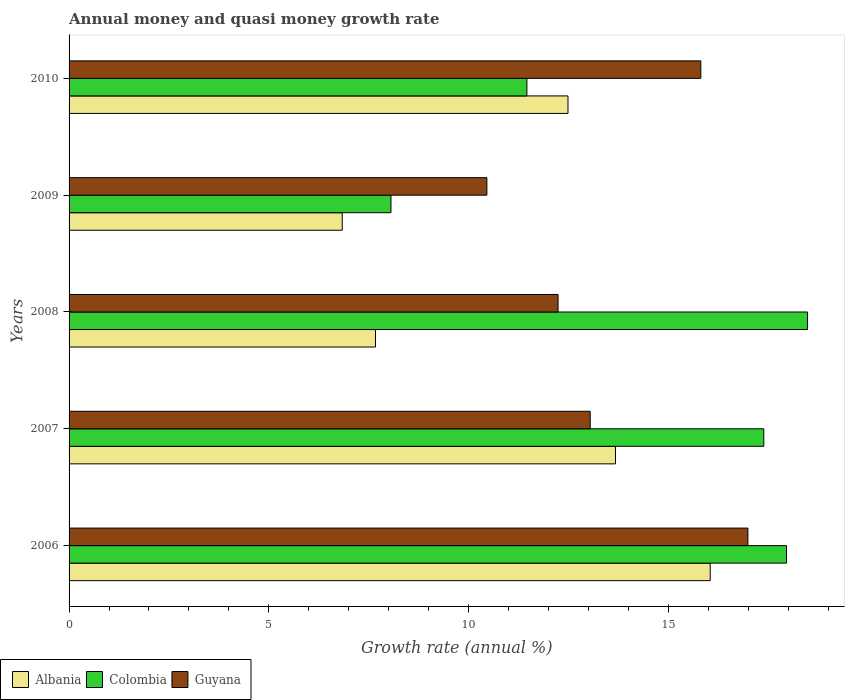Are the number of bars on each tick of the Y-axis equal?
Provide a succinct answer. Yes. What is the label of the 2nd group of bars from the top?
Provide a succinct answer. 2009. In how many cases, is the number of bars for a given year not equal to the number of legend labels?
Your answer should be compact. 0. What is the growth rate in Guyana in 2007?
Give a very brief answer. 13.04. Across all years, what is the maximum growth rate in Colombia?
Your answer should be very brief. 18.48. Across all years, what is the minimum growth rate in Guyana?
Provide a succinct answer. 10.46. In which year was the growth rate in Colombia maximum?
Offer a very short reply. 2008. In which year was the growth rate in Albania minimum?
Your answer should be compact. 2009. What is the total growth rate in Guyana in the graph?
Offer a very short reply. 68.54. What is the difference between the growth rate in Guyana in 2009 and that in 2010?
Your answer should be very brief. -5.35. What is the difference between the growth rate in Albania in 2010 and the growth rate in Guyana in 2007?
Offer a terse response. -0.56. What is the average growth rate in Albania per year?
Keep it short and to the point. 11.34. In the year 2008, what is the difference between the growth rate in Albania and growth rate in Guyana?
Make the answer very short. -4.57. What is the ratio of the growth rate in Guyana in 2008 to that in 2009?
Give a very brief answer. 1.17. Is the growth rate in Albania in 2009 less than that in 2010?
Your answer should be compact. Yes. Is the difference between the growth rate in Albania in 2006 and 2008 greater than the difference between the growth rate in Guyana in 2006 and 2008?
Your answer should be very brief. Yes. What is the difference between the highest and the second highest growth rate in Guyana?
Make the answer very short. 1.18. What is the difference between the highest and the lowest growth rate in Guyana?
Offer a very short reply. 6.53. In how many years, is the growth rate in Albania greater than the average growth rate in Albania taken over all years?
Your answer should be very brief. 3. What does the 3rd bar from the bottom in 2010 represents?
Ensure brevity in your answer.  Guyana. How many years are there in the graph?
Your answer should be very brief. 5. Where does the legend appear in the graph?
Keep it short and to the point. Bottom left. How many legend labels are there?
Your response must be concise. 3. What is the title of the graph?
Keep it short and to the point. Annual money and quasi money growth rate. Does "St. Kitts and Nevis" appear as one of the legend labels in the graph?
Your answer should be very brief. No. What is the label or title of the X-axis?
Your answer should be compact. Growth rate (annual %). What is the Growth rate (annual %) in Albania in 2006?
Give a very brief answer. 16.05. What is the Growth rate (annual %) in Colombia in 2006?
Make the answer very short. 17.95. What is the Growth rate (annual %) of Guyana in 2006?
Your answer should be very brief. 16.99. What is the Growth rate (annual %) of Albania in 2007?
Provide a succinct answer. 13.67. What is the Growth rate (annual %) of Colombia in 2007?
Your answer should be very brief. 17.39. What is the Growth rate (annual %) of Guyana in 2007?
Provide a succinct answer. 13.04. What is the Growth rate (annual %) of Albania in 2008?
Give a very brief answer. 7.67. What is the Growth rate (annual %) in Colombia in 2008?
Offer a terse response. 18.48. What is the Growth rate (annual %) in Guyana in 2008?
Your answer should be compact. 12.24. What is the Growth rate (annual %) of Albania in 2009?
Offer a very short reply. 6.84. What is the Growth rate (annual %) in Colombia in 2009?
Provide a succinct answer. 8.06. What is the Growth rate (annual %) of Guyana in 2009?
Make the answer very short. 10.46. What is the Growth rate (annual %) in Albania in 2010?
Provide a short and direct response. 12.49. What is the Growth rate (annual %) of Colombia in 2010?
Provide a succinct answer. 11.46. What is the Growth rate (annual %) in Guyana in 2010?
Give a very brief answer. 15.81. Across all years, what is the maximum Growth rate (annual %) of Albania?
Your answer should be very brief. 16.05. Across all years, what is the maximum Growth rate (annual %) of Colombia?
Give a very brief answer. 18.48. Across all years, what is the maximum Growth rate (annual %) in Guyana?
Offer a very short reply. 16.99. Across all years, what is the minimum Growth rate (annual %) in Albania?
Offer a very short reply. 6.84. Across all years, what is the minimum Growth rate (annual %) of Colombia?
Provide a succinct answer. 8.06. Across all years, what is the minimum Growth rate (annual %) in Guyana?
Make the answer very short. 10.46. What is the total Growth rate (annual %) of Albania in the graph?
Make the answer very short. 56.71. What is the total Growth rate (annual %) in Colombia in the graph?
Keep it short and to the point. 73.34. What is the total Growth rate (annual %) in Guyana in the graph?
Offer a very short reply. 68.54. What is the difference between the Growth rate (annual %) of Albania in 2006 and that in 2007?
Ensure brevity in your answer.  2.37. What is the difference between the Growth rate (annual %) of Colombia in 2006 and that in 2007?
Provide a short and direct response. 0.57. What is the difference between the Growth rate (annual %) of Guyana in 2006 and that in 2007?
Your answer should be very brief. 3.95. What is the difference between the Growth rate (annual %) of Albania in 2006 and that in 2008?
Give a very brief answer. 8.38. What is the difference between the Growth rate (annual %) in Colombia in 2006 and that in 2008?
Your answer should be compact. -0.53. What is the difference between the Growth rate (annual %) of Guyana in 2006 and that in 2008?
Provide a short and direct response. 4.75. What is the difference between the Growth rate (annual %) of Albania in 2006 and that in 2009?
Provide a short and direct response. 9.21. What is the difference between the Growth rate (annual %) in Colombia in 2006 and that in 2009?
Your answer should be very brief. 9.9. What is the difference between the Growth rate (annual %) in Guyana in 2006 and that in 2009?
Provide a short and direct response. 6.53. What is the difference between the Growth rate (annual %) of Albania in 2006 and that in 2010?
Provide a short and direct response. 3.56. What is the difference between the Growth rate (annual %) in Colombia in 2006 and that in 2010?
Give a very brief answer. 6.5. What is the difference between the Growth rate (annual %) in Guyana in 2006 and that in 2010?
Provide a short and direct response. 1.18. What is the difference between the Growth rate (annual %) of Albania in 2007 and that in 2008?
Keep it short and to the point. 6.01. What is the difference between the Growth rate (annual %) of Colombia in 2007 and that in 2008?
Your response must be concise. -1.1. What is the difference between the Growth rate (annual %) in Guyana in 2007 and that in 2008?
Ensure brevity in your answer.  0.8. What is the difference between the Growth rate (annual %) of Albania in 2007 and that in 2009?
Your response must be concise. 6.84. What is the difference between the Growth rate (annual %) in Colombia in 2007 and that in 2009?
Provide a short and direct response. 9.33. What is the difference between the Growth rate (annual %) of Guyana in 2007 and that in 2009?
Offer a very short reply. 2.59. What is the difference between the Growth rate (annual %) in Albania in 2007 and that in 2010?
Your answer should be very brief. 1.19. What is the difference between the Growth rate (annual %) in Colombia in 2007 and that in 2010?
Give a very brief answer. 5.93. What is the difference between the Growth rate (annual %) of Guyana in 2007 and that in 2010?
Your answer should be compact. -2.77. What is the difference between the Growth rate (annual %) in Albania in 2008 and that in 2009?
Offer a terse response. 0.83. What is the difference between the Growth rate (annual %) of Colombia in 2008 and that in 2009?
Ensure brevity in your answer.  10.43. What is the difference between the Growth rate (annual %) in Guyana in 2008 and that in 2009?
Your answer should be compact. 1.78. What is the difference between the Growth rate (annual %) of Albania in 2008 and that in 2010?
Offer a very short reply. -4.82. What is the difference between the Growth rate (annual %) in Colombia in 2008 and that in 2010?
Provide a succinct answer. 7.02. What is the difference between the Growth rate (annual %) in Guyana in 2008 and that in 2010?
Your answer should be very brief. -3.57. What is the difference between the Growth rate (annual %) of Albania in 2009 and that in 2010?
Give a very brief answer. -5.65. What is the difference between the Growth rate (annual %) in Colombia in 2009 and that in 2010?
Ensure brevity in your answer.  -3.4. What is the difference between the Growth rate (annual %) in Guyana in 2009 and that in 2010?
Provide a short and direct response. -5.35. What is the difference between the Growth rate (annual %) in Albania in 2006 and the Growth rate (annual %) in Colombia in 2007?
Your answer should be very brief. -1.34. What is the difference between the Growth rate (annual %) of Albania in 2006 and the Growth rate (annual %) of Guyana in 2007?
Ensure brevity in your answer.  3. What is the difference between the Growth rate (annual %) of Colombia in 2006 and the Growth rate (annual %) of Guyana in 2007?
Keep it short and to the point. 4.91. What is the difference between the Growth rate (annual %) in Albania in 2006 and the Growth rate (annual %) in Colombia in 2008?
Your answer should be very brief. -2.44. What is the difference between the Growth rate (annual %) of Albania in 2006 and the Growth rate (annual %) of Guyana in 2008?
Your answer should be very brief. 3.81. What is the difference between the Growth rate (annual %) of Colombia in 2006 and the Growth rate (annual %) of Guyana in 2008?
Provide a short and direct response. 5.72. What is the difference between the Growth rate (annual %) in Albania in 2006 and the Growth rate (annual %) in Colombia in 2009?
Provide a short and direct response. 7.99. What is the difference between the Growth rate (annual %) in Albania in 2006 and the Growth rate (annual %) in Guyana in 2009?
Offer a terse response. 5.59. What is the difference between the Growth rate (annual %) in Colombia in 2006 and the Growth rate (annual %) in Guyana in 2009?
Keep it short and to the point. 7.5. What is the difference between the Growth rate (annual %) of Albania in 2006 and the Growth rate (annual %) of Colombia in 2010?
Keep it short and to the point. 4.59. What is the difference between the Growth rate (annual %) in Albania in 2006 and the Growth rate (annual %) in Guyana in 2010?
Make the answer very short. 0.24. What is the difference between the Growth rate (annual %) in Colombia in 2006 and the Growth rate (annual %) in Guyana in 2010?
Give a very brief answer. 2.14. What is the difference between the Growth rate (annual %) in Albania in 2007 and the Growth rate (annual %) in Colombia in 2008?
Make the answer very short. -4.81. What is the difference between the Growth rate (annual %) in Albania in 2007 and the Growth rate (annual %) in Guyana in 2008?
Provide a short and direct response. 1.44. What is the difference between the Growth rate (annual %) in Colombia in 2007 and the Growth rate (annual %) in Guyana in 2008?
Give a very brief answer. 5.15. What is the difference between the Growth rate (annual %) in Albania in 2007 and the Growth rate (annual %) in Colombia in 2009?
Offer a very short reply. 5.62. What is the difference between the Growth rate (annual %) of Albania in 2007 and the Growth rate (annual %) of Guyana in 2009?
Keep it short and to the point. 3.22. What is the difference between the Growth rate (annual %) in Colombia in 2007 and the Growth rate (annual %) in Guyana in 2009?
Ensure brevity in your answer.  6.93. What is the difference between the Growth rate (annual %) in Albania in 2007 and the Growth rate (annual %) in Colombia in 2010?
Give a very brief answer. 2.22. What is the difference between the Growth rate (annual %) of Albania in 2007 and the Growth rate (annual %) of Guyana in 2010?
Provide a succinct answer. -2.14. What is the difference between the Growth rate (annual %) in Colombia in 2007 and the Growth rate (annual %) in Guyana in 2010?
Offer a terse response. 1.58. What is the difference between the Growth rate (annual %) in Albania in 2008 and the Growth rate (annual %) in Colombia in 2009?
Offer a terse response. -0.39. What is the difference between the Growth rate (annual %) of Albania in 2008 and the Growth rate (annual %) of Guyana in 2009?
Your answer should be compact. -2.79. What is the difference between the Growth rate (annual %) of Colombia in 2008 and the Growth rate (annual %) of Guyana in 2009?
Ensure brevity in your answer.  8.03. What is the difference between the Growth rate (annual %) of Albania in 2008 and the Growth rate (annual %) of Colombia in 2010?
Offer a very short reply. -3.79. What is the difference between the Growth rate (annual %) in Albania in 2008 and the Growth rate (annual %) in Guyana in 2010?
Offer a very short reply. -8.14. What is the difference between the Growth rate (annual %) of Colombia in 2008 and the Growth rate (annual %) of Guyana in 2010?
Offer a very short reply. 2.67. What is the difference between the Growth rate (annual %) in Albania in 2009 and the Growth rate (annual %) in Colombia in 2010?
Offer a very short reply. -4.62. What is the difference between the Growth rate (annual %) in Albania in 2009 and the Growth rate (annual %) in Guyana in 2010?
Ensure brevity in your answer.  -8.97. What is the difference between the Growth rate (annual %) in Colombia in 2009 and the Growth rate (annual %) in Guyana in 2010?
Your answer should be very brief. -7.75. What is the average Growth rate (annual %) in Albania per year?
Your response must be concise. 11.34. What is the average Growth rate (annual %) of Colombia per year?
Provide a succinct answer. 14.67. What is the average Growth rate (annual %) of Guyana per year?
Give a very brief answer. 13.71. In the year 2006, what is the difference between the Growth rate (annual %) in Albania and Growth rate (annual %) in Colombia?
Offer a very short reply. -1.91. In the year 2006, what is the difference between the Growth rate (annual %) of Albania and Growth rate (annual %) of Guyana?
Offer a very short reply. -0.94. In the year 2006, what is the difference between the Growth rate (annual %) of Colombia and Growth rate (annual %) of Guyana?
Ensure brevity in your answer.  0.97. In the year 2007, what is the difference between the Growth rate (annual %) of Albania and Growth rate (annual %) of Colombia?
Ensure brevity in your answer.  -3.71. In the year 2007, what is the difference between the Growth rate (annual %) in Albania and Growth rate (annual %) in Guyana?
Give a very brief answer. 0.63. In the year 2007, what is the difference between the Growth rate (annual %) in Colombia and Growth rate (annual %) in Guyana?
Ensure brevity in your answer.  4.34. In the year 2008, what is the difference between the Growth rate (annual %) in Albania and Growth rate (annual %) in Colombia?
Offer a terse response. -10.81. In the year 2008, what is the difference between the Growth rate (annual %) in Albania and Growth rate (annual %) in Guyana?
Make the answer very short. -4.57. In the year 2008, what is the difference between the Growth rate (annual %) of Colombia and Growth rate (annual %) of Guyana?
Your answer should be compact. 6.24. In the year 2009, what is the difference between the Growth rate (annual %) of Albania and Growth rate (annual %) of Colombia?
Ensure brevity in your answer.  -1.22. In the year 2009, what is the difference between the Growth rate (annual %) of Albania and Growth rate (annual %) of Guyana?
Your response must be concise. -3.62. In the year 2009, what is the difference between the Growth rate (annual %) of Colombia and Growth rate (annual %) of Guyana?
Your response must be concise. -2.4. In the year 2010, what is the difference between the Growth rate (annual %) of Albania and Growth rate (annual %) of Colombia?
Give a very brief answer. 1.03. In the year 2010, what is the difference between the Growth rate (annual %) of Albania and Growth rate (annual %) of Guyana?
Provide a succinct answer. -3.32. In the year 2010, what is the difference between the Growth rate (annual %) of Colombia and Growth rate (annual %) of Guyana?
Provide a succinct answer. -4.35. What is the ratio of the Growth rate (annual %) of Albania in 2006 to that in 2007?
Provide a short and direct response. 1.17. What is the ratio of the Growth rate (annual %) in Colombia in 2006 to that in 2007?
Your answer should be compact. 1.03. What is the ratio of the Growth rate (annual %) of Guyana in 2006 to that in 2007?
Offer a terse response. 1.3. What is the ratio of the Growth rate (annual %) of Albania in 2006 to that in 2008?
Provide a succinct answer. 2.09. What is the ratio of the Growth rate (annual %) of Colombia in 2006 to that in 2008?
Offer a very short reply. 0.97. What is the ratio of the Growth rate (annual %) of Guyana in 2006 to that in 2008?
Your answer should be very brief. 1.39. What is the ratio of the Growth rate (annual %) of Albania in 2006 to that in 2009?
Provide a short and direct response. 2.35. What is the ratio of the Growth rate (annual %) of Colombia in 2006 to that in 2009?
Offer a terse response. 2.23. What is the ratio of the Growth rate (annual %) in Guyana in 2006 to that in 2009?
Make the answer very short. 1.62. What is the ratio of the Growth rate (annual %) in Albania in 2006 to that in 2010?
Provide a short and direct response. 1.29. What is the ratio of the Growth rate (annual %) of Colombia in 2006 to that in 2010?
Provide a short and direct response. 1.57. What is the ratio of the Growth rate (annual %) in Guyana in 2006 to that in 2010?
Your answer should be compact. 1.07. What is the ratio of the Growth rate (annual %) of Albania in 2007 to that in 2008?
Provide a succinct answer. 1.78. What is the ratio of the Growth rate (annual %) of Colombia in 2007 to that in 2008?
Keep it short and to the point. 0.94. What is the ratio of the Growth rate (annual %) in Guyana in 2007 to that in 2008?
Give a very brief answer. 1.07. What is the ratio of the Growth rate (annual %) of Albania in 2007 to that in 2009?
Your answer should be compact. 2. What is the ratio of the Growth rate (annual %) of Colombia in 2007 to that in 2009?
Your response must be concise. 2.16. What is the ratio of the Growth rate (annual %) of Guyana in 2007 to that in 2009?
Keep it short and to the point. 1.25. What is the ratio of the Growth rate (annual %) of Albania in 2007 to that in 2010?
Keep it short and to the point. 1.1. What is the ratio of the Growth rate (annual %) in Colombia in 2007 to that in 2010?
Your response must be concise. 1.52. What is the ratio of the Growth rate (annual %) of Guyana in 2007 to that in 2010?
Give a very brief answer. 0.82. What is the ratio of the Growth rate (annual %) in Albania in 2008 to that in 2009?
Offer a terse response. 1.12. What is the ratio of the Growth rate (annual %) of Colombia in 2008 to that in 2009?
Keep it short and to the point. 2.29. What is the ratio of the Growth rate (annual %) of Guyana in 2008 to that in 2009?
Your answer should be compact. 1.17. What is the ratio of the Growth rate (annual %) of Albania in 2008 to that in 2010?
Give a very brief answer. 0.61. What is the ratio of the Growth rate (annual %) of Colombia in 2008 to that in 2010?
Your answer should be very brief. 1.61. What is the ratio of the Growth rate (annual %) of Guyana in 2008 to that in 2010?
Keep it short and to the point. 0.77. What is the ratio of the Growth rate (annual %) of Albania in 2009 to that in 2010?
Offer a very short reply. 0.55. What is the ratio of the Growth rate (annual %) in Colombia in 2009 to that in 2010?
Provide a succinct answer. 0.7. What is the ratio of the Growth rate (annual %) in Guyana in 2009 to that in 2010?
Your answer should be very brief. 0.66. What is the difference between the highest and the second highest Growth rate (annual %) in Albania?
Ensure brevity in your answer.  2.37. What is the difference between the highest and the second highest Growth rate (annual %) of Colombia?
Your answer should be very brief. 0.53. What is the difference between the highest and the second highest Growth rate (annual %) of Guyana?
Make the answer very short. 1.18. What is the difference between the highest and the lowest Growth rate (annual %) of Albania?
Offer a terse response. 9.21. What is the difference between the highest and the lowest Growth rate (annual %) of Colombia?
Keep it short and to the point. 10.43. What is the difference between the highest and the lowest Growth rate (annual %) in Guyana?
Offer a terse response. 6.53. 